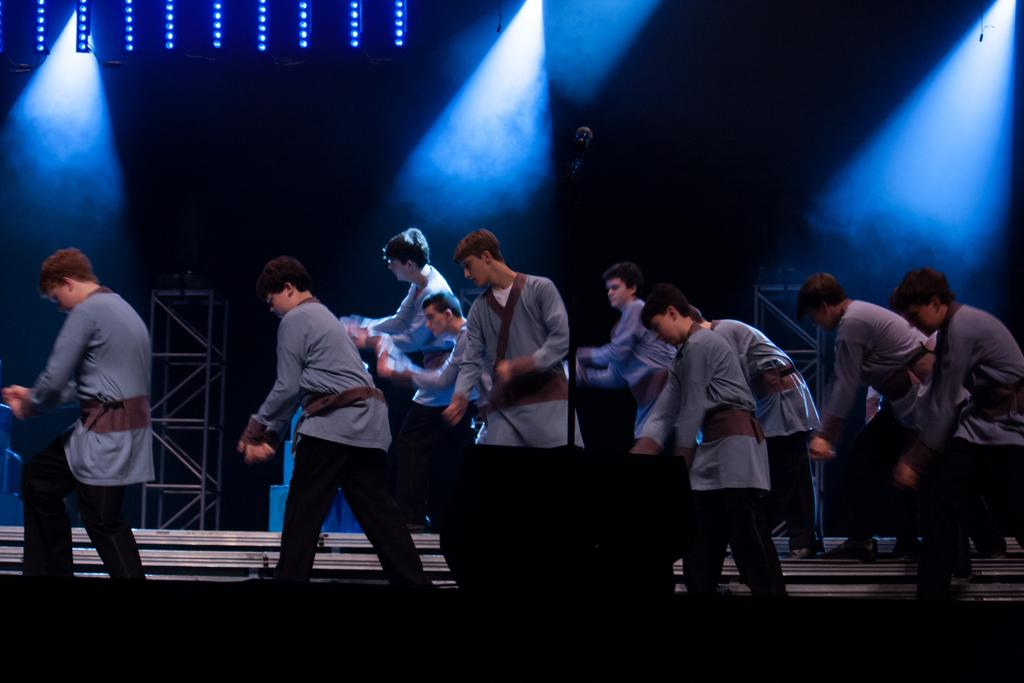How many people are in the image? There are many people in the image. What are the people wearing? The people are wearing grey shirts. Where are the people performing? The people are performing on a stage. What can be seen in the background of the image? There are lights and pillars in the background of the image. What type of business is being conducted in the image? There is no indication of a business being conducted in the image; it features people performing on a stage. 